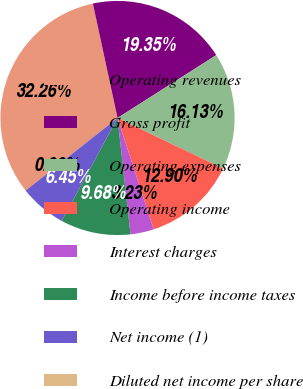<chart> <loc_0><loc_0><loc_500><loc_500><pie_chart><fcel>Operating revenues<fcel>Gross profit<fcel>Operating expenses<fcel>Operating income<fcel>Interest charges<fcel>Income before income taxes<fcel>Net income (1)<fcel>Diluted net income per share<nl><fcel>32.26%<fcel>19.35%<fcel>16.13%<fcel>12.9%<fcel>3.23%<fcel>9.68%<fcel>6.45%<fcel>0.0%<nl></chart> 